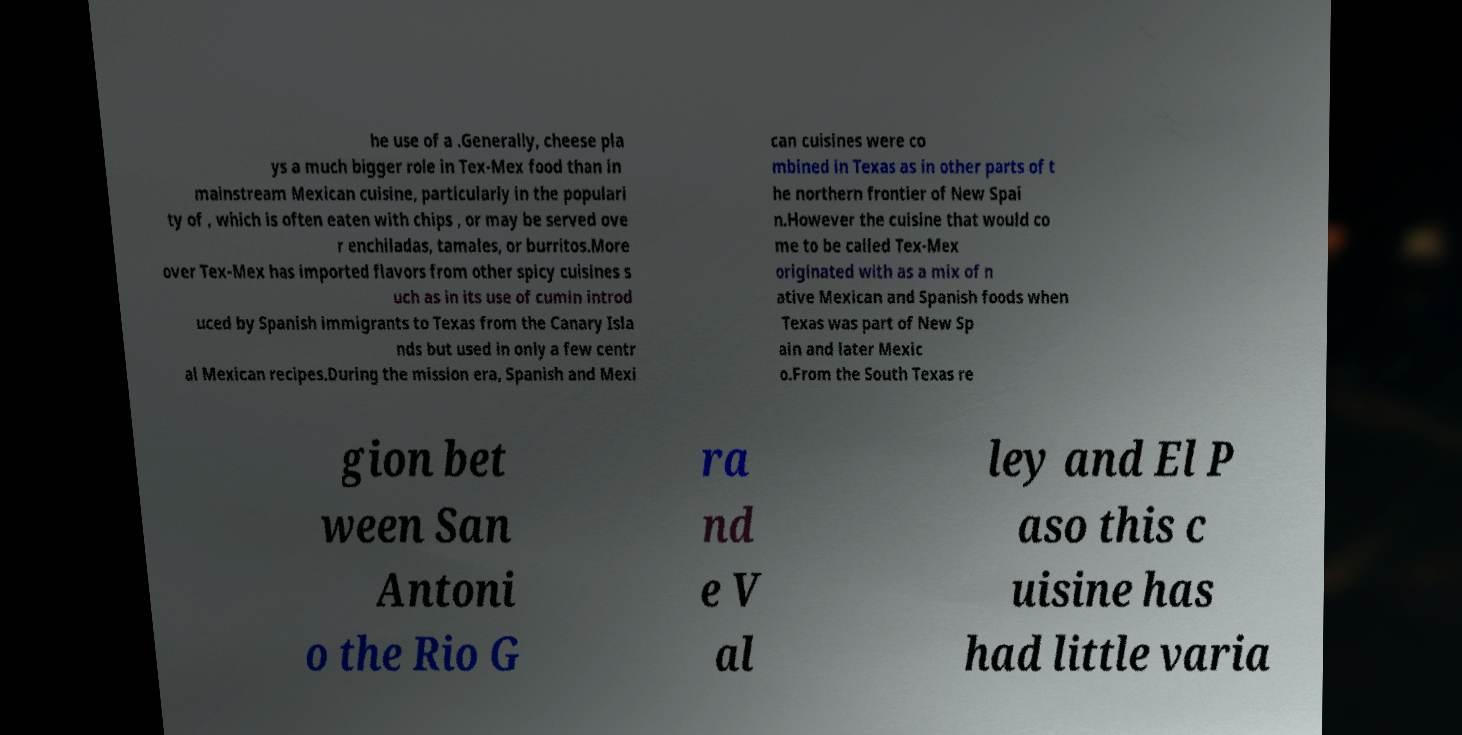For documentation purposes, I need the text within this image transcribed. Could you provide that? he use of a .Generally, cheese pla ys a much bigger role in Tex-Mex food than in mainstream Mexican cuisine, particularly in the populari ty of , which is often eaten with chips , or may be served ove r enchiladas, tamales, or burritos.More over Tex-Mex has imported flavors from other spicy cuisines s uch as in its use of cumin introd uced by Spanish immigrants to Texas from the Canary Isla nds but used in only a few centr al Mexican recipes.During the mission era, Spanish and Mexi can cuisines were co mbined in Texas as in other parts of t he northern frontier of New Spai n.However the cuisine that would co me to be called Tex-Mex originated with as a mix of n ative Mexican and Spanish foods when Texas was part of New Sp ain and later Mexic o.From the South Texas re gion bet ween San Antoni o the Rio G ra nd e V al ley and El P aso this c uisine has had little varia 